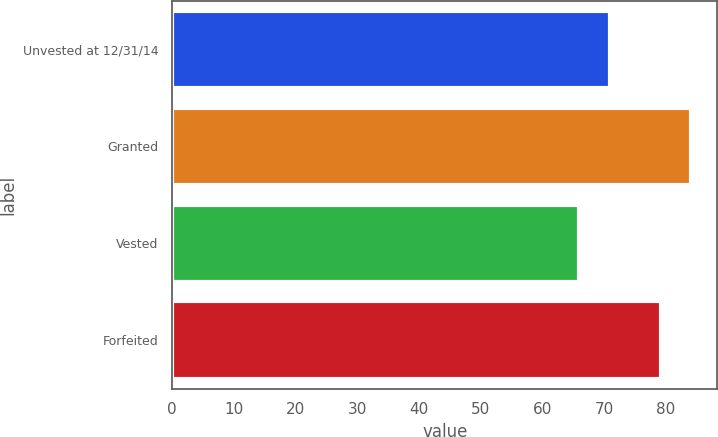Convert chart to OTSL. <chart><loc_0><loc_0><loc_500><loc_500><bar_chart><fcel>Unvested at 12/31/14<fcel>Granted<fcel>Vested<fcel>Forfeited<nl><fcel>70.9<fcel>84.14<fcel>66<fcel>79.2<nl></chart> 